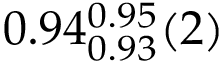<formula> <loc_0><loc_0><loc_500><loc_500>0 . 9 4 _ { 0 . 9 3 } ^ { 0 . 9 5 } ( 2 )</formula> 